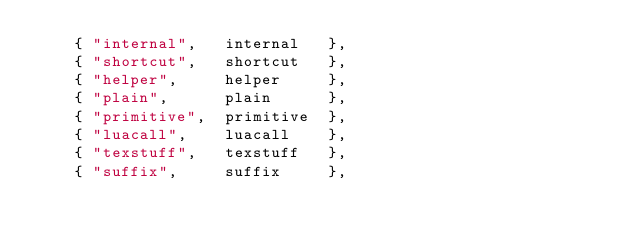Convert code to text. <code><loc_0><loc_0><loc_500><loc_500><_Lua_>    { "internal",   internal   },
    { "shortcut",   shortcut   },
    { "helper",     helper     },
    { "plain",      plain      },
    { "primitive",  primitive  },
    { "luacall",    luacall    },
    { "texstuff",   texstuff   },
    { "suffix",     suffix     },</code> 